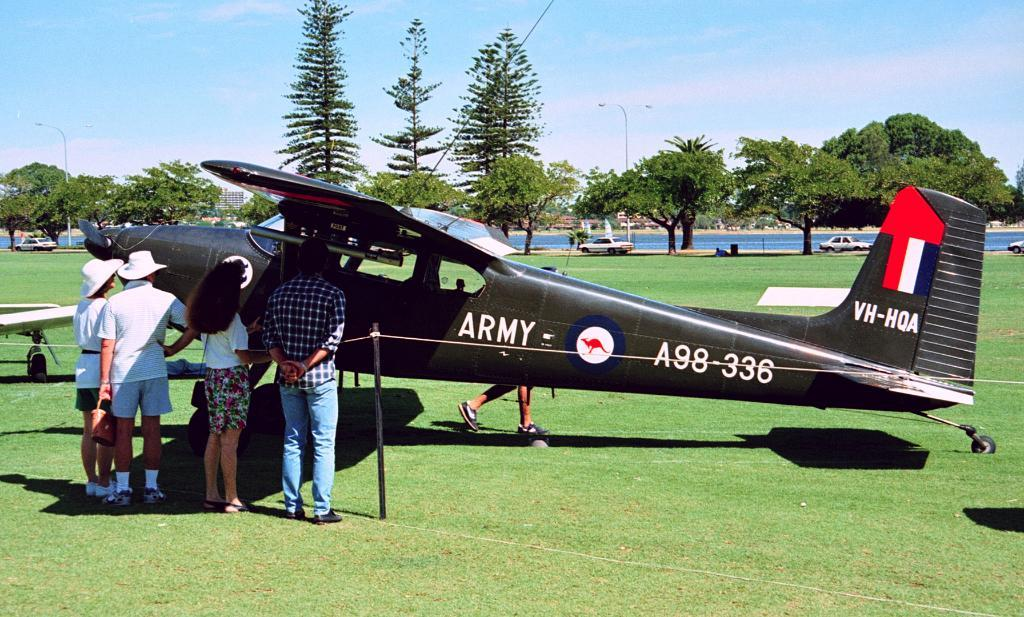Provide a one-sentence caption for the provided image. People are standing in front of black propeller plane with "Army " sign on it's side. 